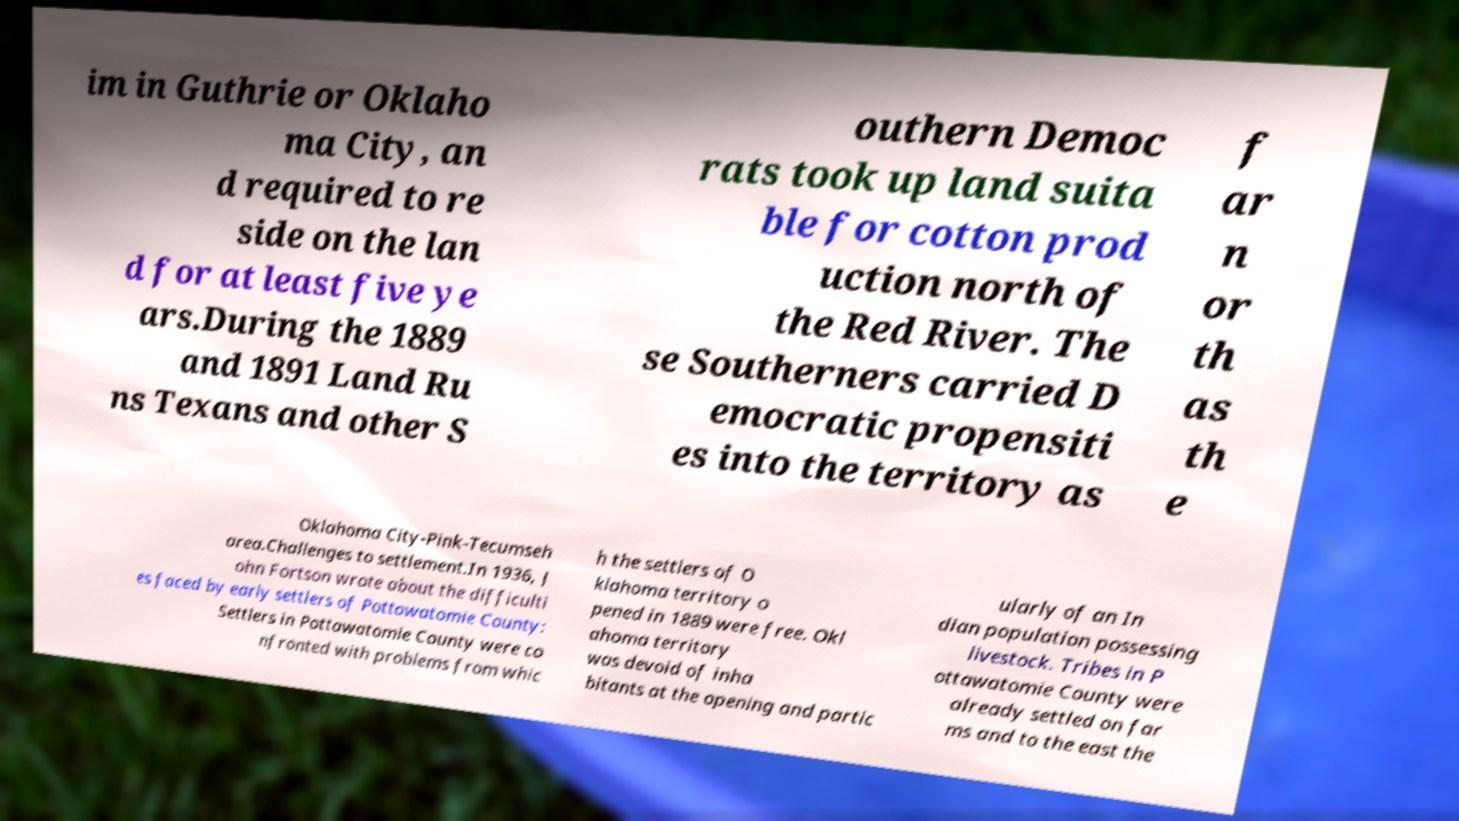I need the written content from this picture converted into text. Can you do that? im in Guthrie or Oklaho ma City, an d required to re side on the lan d for at least five ye ars.During the 1889 and 1891 Land Ru ns Texans and other S outhern Democ rats took up land suita ble for cotton prod uction north of the Red River. The se Southerners carried D emocratic propensiti es into the territory as f ar n or th as th e Oklahoma City-Pink-Tecumseh area.Challenges to settlement.In 1936, J ohn Fortson wrote about the difficulti es faced by early settlers of Pottawatomie County: Settlers in Pottawatomie County were co nfronted with problems from whic h the settlers of O klahoma territory o pened in 1889 were free. Okl ahoma territory was devoid of inha bitants at the opening and partic ularly of an In dian population possessing livestock. Tribes in P ottawatomie County were already settled on far ms and to the east the 